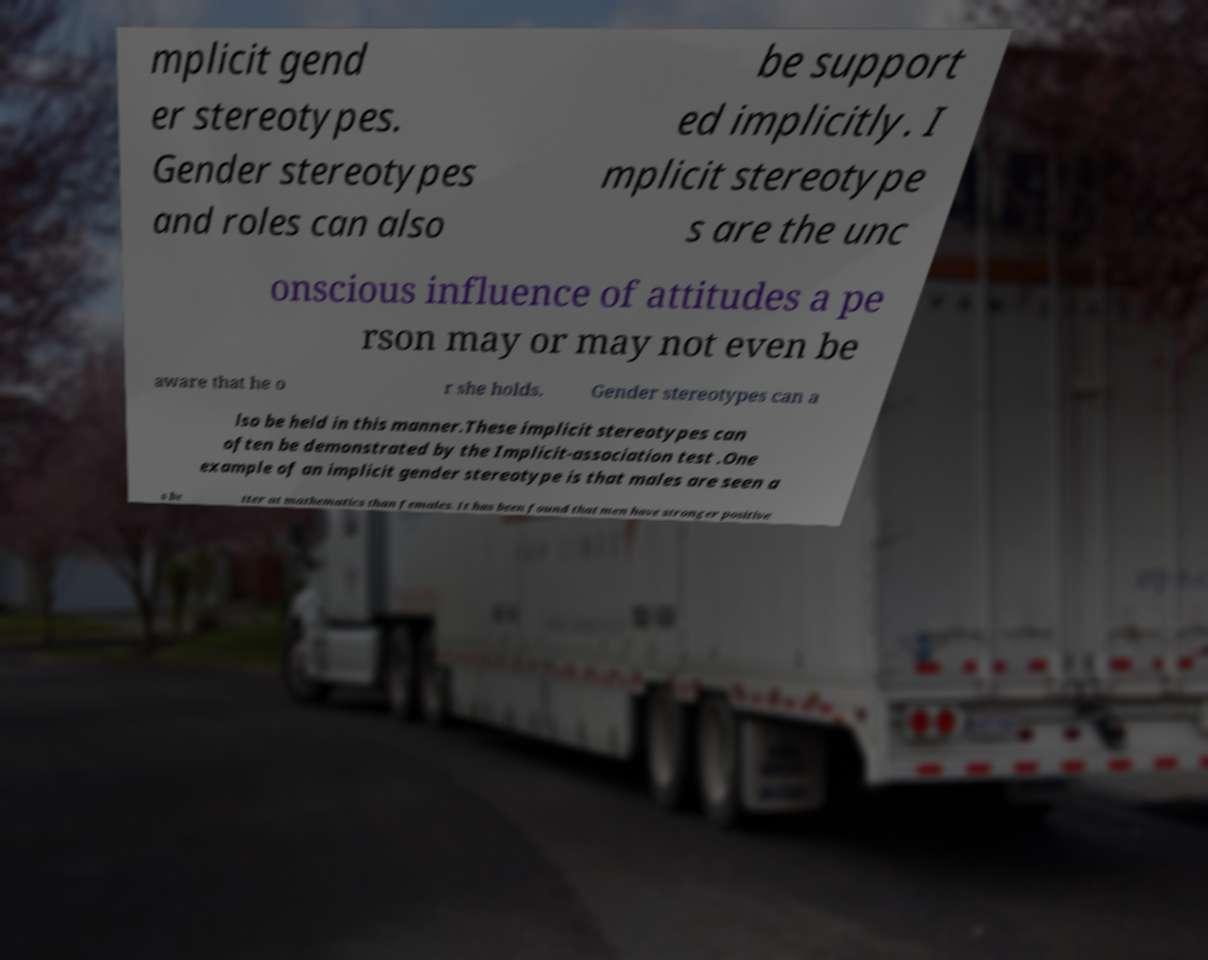Could you assist in decoding the text presented in this image and type it out clearly? mplicit gend er stereotypes. Gender stereotypes and roles can also be support ed implicitly. I mplicit stereotype s are the unc onscious influence of attitudes a pe rson may or may not even be aware that he o r she holds. Gender stereotypes can a lso be held in this manner.These implicit stereotypes can often be demonstrated by the Implicit-association test .One example of an implicit gender stereotype is that males are seen a s be tter at mathematics than females. It has been found that men have stronger positive 